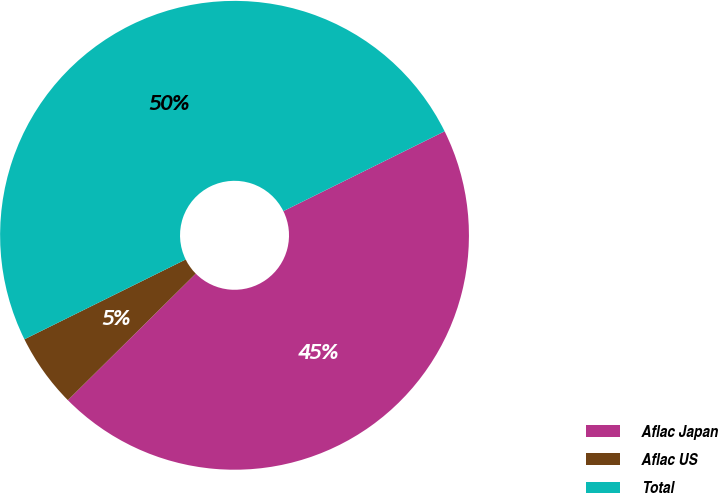Convert chart. <chart><loc_0><loc_0><loc_500><loc_500><pie_chart><fcel>Aflac Japan<fcel>Aflac US<fcel>Total<nl><fcel>44.9%<fcel>5.1%<fcel>50.0%<nl></chart> 